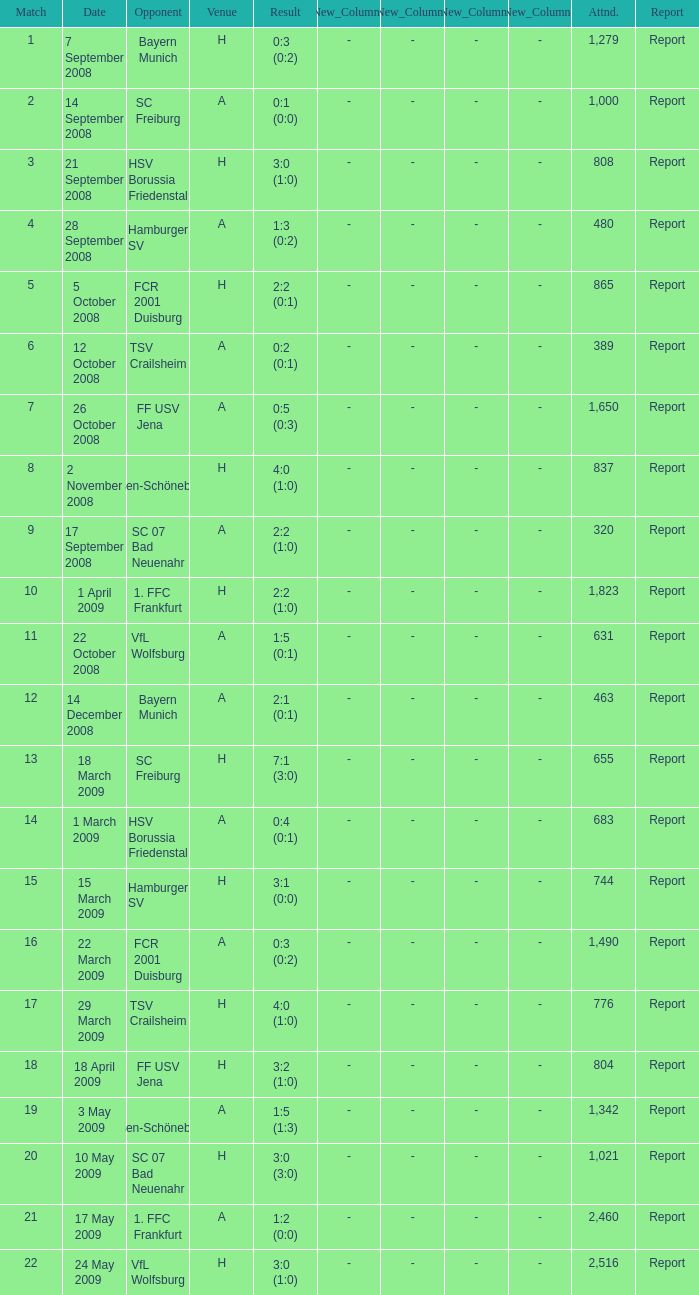What is the match number that had a result of 0:5 (0:3)? 1.0. Can you parse all the data within this table? {'header': ['Match', 'Date', 'Opponent', 'Venue', 'Result', 'New_Column1', 'New_Column2', 'New_Column3', 'New_Column4', 'Attnd.', 'Report'], 'rows': [['1', '7 September 2008', 'Bayern Munich', 'H', '0:3 (0:2)', '-', '-', '-', '-', '1,279', 'Report'], ['2', '14 September 2008', 'SC Freiburg', 'A', '0:1 (0:0)', '-', '-', '-', '-', '1,000', 'Report'], ['3', '21 September 2008', 'HSV Borussia Friedenstal', 'H', '3:0 (1:0)', '-', '-', '-', '-', '808', 'Report'], ['4', '28 September 2008', 'Hamburger SV', 'A', '1:3 (0:2)', '-', '-', '-', '-', '480', 'Report'], ['5', '5 October 2008', 'FCR 2001 Duisburg', 'H', '2:2 (0:1)', '-', '-', '-', '-', '865', 'Report'], ['6', '12 October 2008', 'TSV Crailsheim', 'A', '0:2 (0:1)', '-', '-', '-', '-', '389', 'Report'], ['7', '26 October 2008', 'FF USV Jena', 'A', '0:5 (0:3)', '-', '-', '-', '-', '1,650', 'Report'], ['8', '2 November 2008', 'SG Essen-Schönebeck', 'H', '4:0 (1:0)', '-', '-', '-', '-', '837', 'Report'], ['9', '17 September 2008', 'SC 07 Bad Neuenahr', 'A', '2:2 (1:0)', '-', '-', '-', '-', '320', 'Report'], ['10', '1 April 2009', '1. FFC Frankfurt', 'H', '2:2 (1:0)', '-', '-', '-', '-', '1,823', 'Report'], ['11', '22 October 2008', 'VfL Wolfsburg', 'A', '1:5 (0:1)', '-', '-', '-', '-', '631', 'Report'], ['12', '14 December 2008', 'Bayern Munich', 'A', '2:1 (0:1)', '-', '-', '-', '-', '463', 'Report'], ['13', '18 March 2009', 'SC Freiburg', 'H', '7:1 (3:0)', '-', '-', '-', '-', '655', 'Report'], ['14', '1 March 2009', 'HSV Borussia Friedenstal', 'A', '0:4 (0:1)', '-', '-', '-', '-', '683', 'Report'], ['15', '15 March 2009', 'Hamburger SV', 'H', '3:1 (0:0)', '-', '-', '-', '-', '744', 'Report'], ['16', '22 March 2009', 'FCR 2001 Duisburg', 'A', '0:3 (0:2)', '-', '-', '-', '-', '1,490', 'Report'], ['17', '29 March 2009', 'TSV Crailsheim', 'H', '4:0 (1:0)', '-', '-', '-', '-', '776', 'Report'], ['18', '18 April 2009', 'FF USV Jena', 'H', '3:2 (1:0)', '-', '-', '-', '-', '804', 'Report'], ['19', '3 May 2009', 'SG Essen-Schönebeck', 'A', '1:5 (1:3)', '-', '-', '-', '-', '1,342', 'Report'], ['20', '10 May 2009', 'SC 07 Bad Neuenahr', 'H', '3:0 (3:0)', '-', '-', '-', '-', '1,021', 'Report'], ['21', '17 May 2009', '1. FFC Frankfurt', 'A', '1:2 (0:0)', '-', '-', '-', '-', '2,460', 'Report'], ['22', '24 May 2009', 'VfL Wolfsburg', 'H', '3:0 (1:0)', '-', '-', '-', '-', '2,516', 'Report']]} 